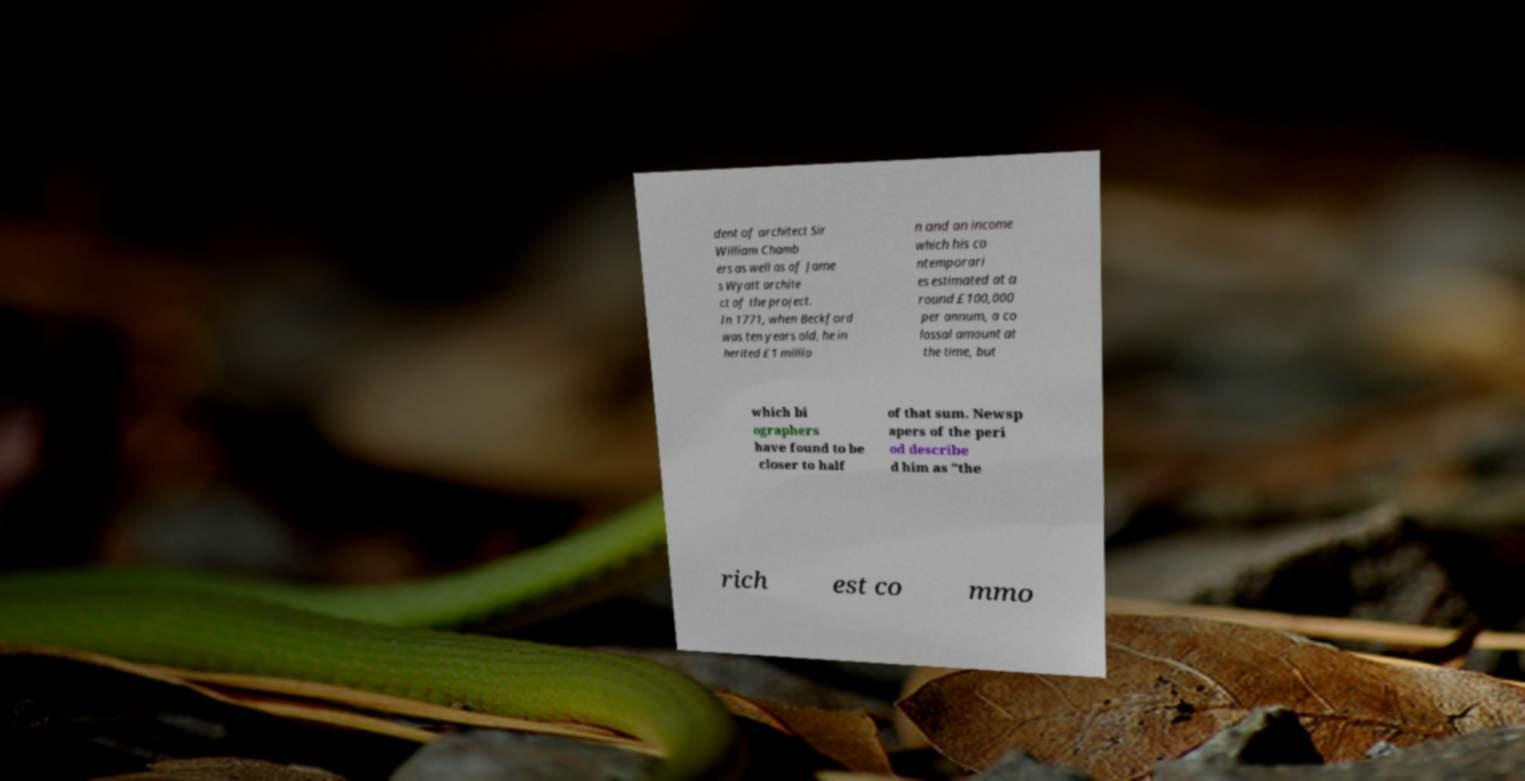What messages or text are displayed in this image? I need them in a readable, typed format. dent of architect Sir William Chamb ers as well as of Jame s Wyatt archite ct of the project. In 1771, when Beckford was ten years old, he in herited £1 millio n and an income which his co ntemporari es estimated at a round £100,000 per annum, a co lossal amount at the time, but which bi ographers have found to be closer to half of that sum. Newsp apers of the peri od describe d him as "the rich est co mmo 